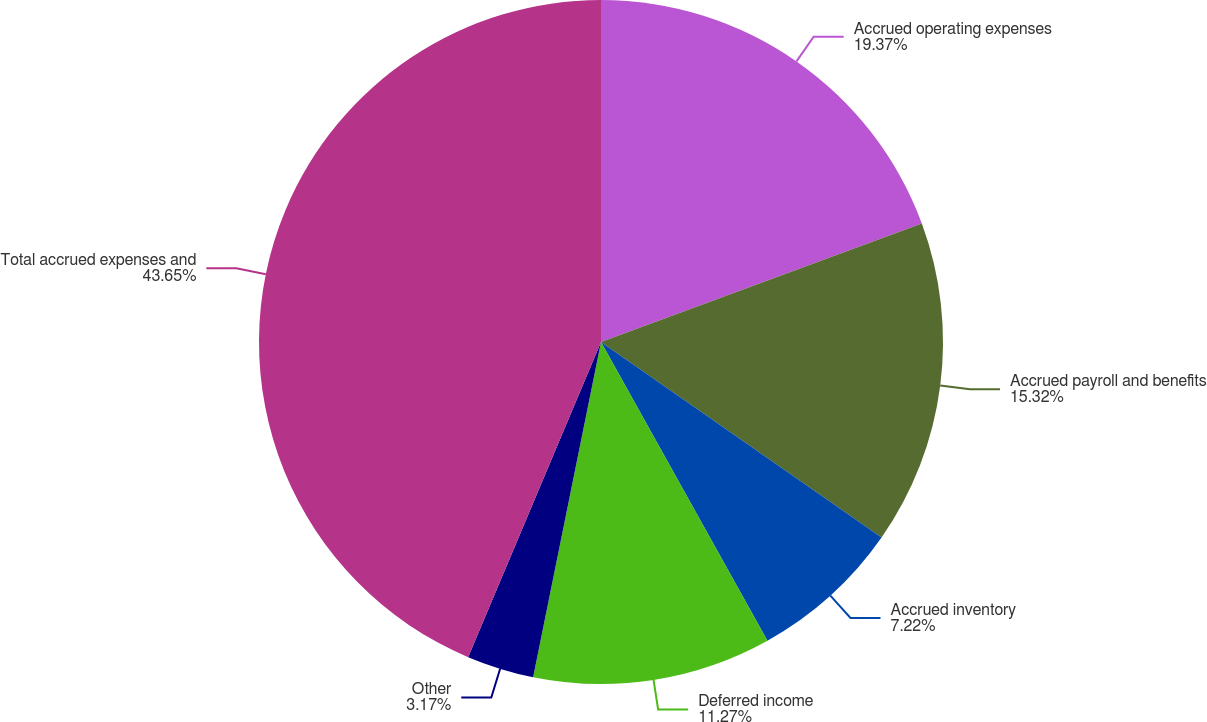Convert chart. <chart><loc_0><loc_0><loc_500><loc_500><pie_chart><fcel>Accrued operating expenses<fcel>Accrued payroll and benefits<fcel>Accrued inventory<fcel>Deferred income<fcel>Other<fcel>Total accrued expenses and<nl><fcel>19.37%<fcel>15.32%<fcel>7.22%<fcel>11.27%<fcel>3.17%<fcel>43.65%<nl></chart> 